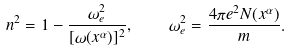Convert formula to latex. <formula><loc_0><loc_0><loc_500><loc_500>n ^ { 2 } = 1 - \frac { \omega _ { e } ^ { 2 } } { [ \omega ( x ^ { \alpha } ) ] ^ { 2 } } , \quad \omega _ { e } ^ { 2 } = \frac { 4 \pi e ^ { 2 } N ( x ^ { \alpha } ) } { m } .</formula> 